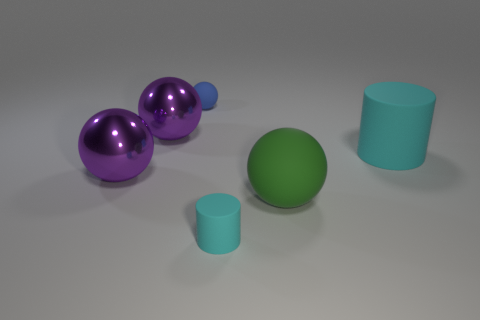What is the shape of the tiny thing that is the same color as the big matte cylinder?
Provide a short and direct response. Cylinder. Are there any other rubber cylinders of the same color as the big matte cylinder?
Offer a terse response. Yes. There is a tiny object in front of the small blue rubber sphere; does it have the same color as the small sphere?
Your response must be concise. No. Are there more tiny matte cylinders behind the blue object than balls that are on the left side of the large matte cylinder?
Ensure brevity in your answer.  No. Are there more matte balls than large matte spheres?
Your answer should be very brief. Yes. There is a rubber thing that is behind the large green rubber ball and to the left of the large rubber cylinder; how big is it?
Provide a succinct answer. Small. What shape is the blue thing?
Ensure brevity in your answer.  Sphere. Are there more tiny blue rubber spheres left of the green thing than large red balls?
Ensure brevity in your answer.  Yes. The small object in front of the cyan matte cylinder that is behind the rubber object that is in front of the big green thing is what shape?
Offer a terse response. Cylinder. Is the size of the sphere on the right side of the blue rubber thing the same as the blue rubber object?
Provide a short and direct response. No. 